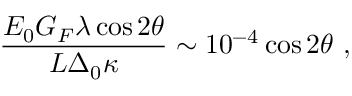<formula> <loc_0><loc_0><loc_500><loc_500>\frac { E _ { 0 } G _ { F } \lambda \cos 2 \theta } { L \Delta _ { 0 } \kappa } \sim 1 0 ^ { - 4 } \cos 2 \theta \ ,</formula> 